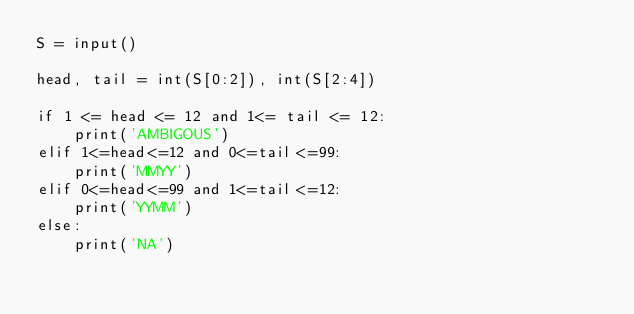<code> <loc_0><loc_0><loc_500><loc_500><_Python_>S = input()

head, tail = int(S[0:2]), int(S[2:4])

if 1 <= head <= 12 and 1<= tail <= 12:
    print('AMBIGOUS')
elif 1<=head<=12 and 0<=tail<=99:
    print('MMYY')
elif 0<=head<=99 and 1<=tail<=12:
    print('YYMM')
else:
    print('NA')</code> 